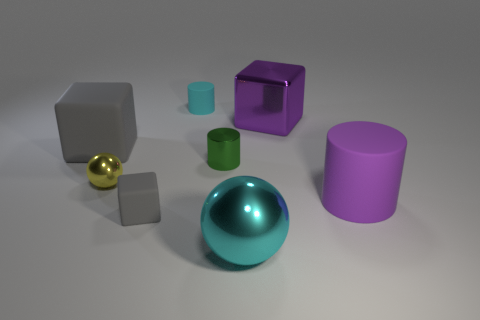How many matte things are there?
Your answer should be very brief. 4. There is a large object on the right side of the purple metallic block; is its shape the same as the green metal object?
Offer a very short reply. Yes. What is the material of the gray cube that is the same size as the cyan matte thing?
Make the answer very short. Rubber. Are there any red spheres made of the same material as the large purple cylinder?
Your answer should be compact. No. There is a tiny cyan rubber object; is its shape the same as the cyan object that is on the right side of the small rubber cylinder?
Provide a succinct answer. No. What number of gray cubes are both on the right side of the large gray matte cube and behind the small ball?
Your answer should be very brief. 0. Is the green cylinder made of the same material as the gray object on the left side of the tiny gray object?
Your response must be concise. No. Are there the same number of yellow metallic spheres on the right side of the big purple rubber cylinder and green cylinders?
Give a very brief answer. No. What is the color of the small shiny thing that is to the right of the tiny cyan rubber object?
Your answer should be compact. Green. What number of other objects are there of the same color as the tiny metallic sphere?
Give a very brief answer. 0. 